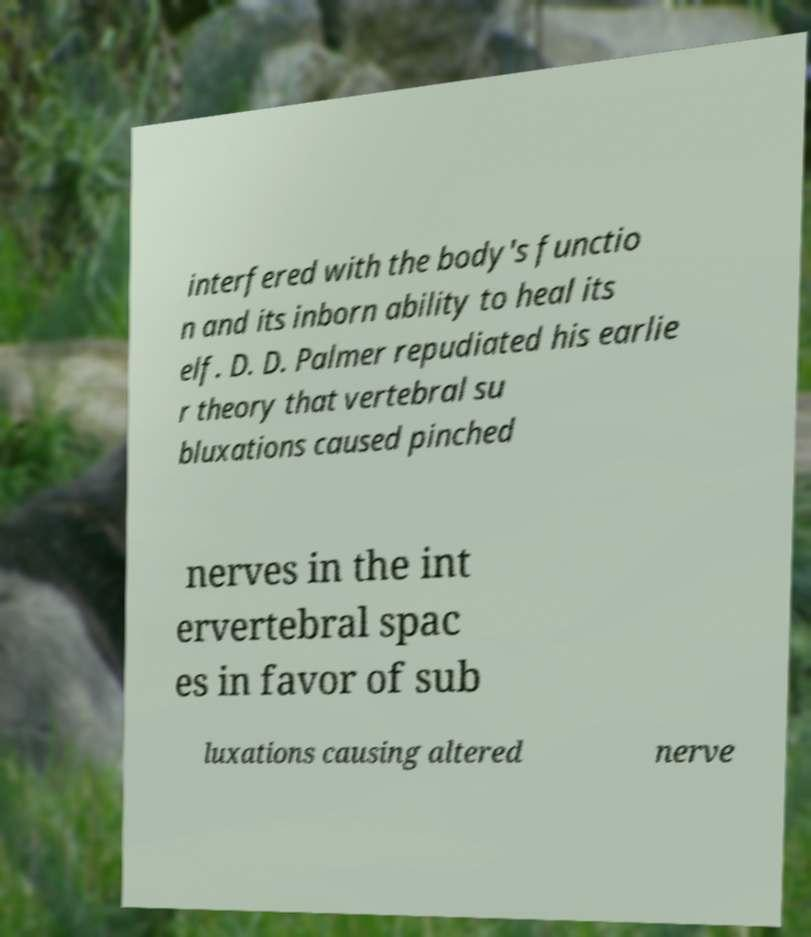Could you extract and type out the text from this image? interfered with the body's functio n and its inborn ability to heal its elf. D. D. Palmer repudiated his earlie r theory that vertebral su bluxations caused pinched nerves in the int ervertebral spac es in favor of sub luxations causing altered nerve 